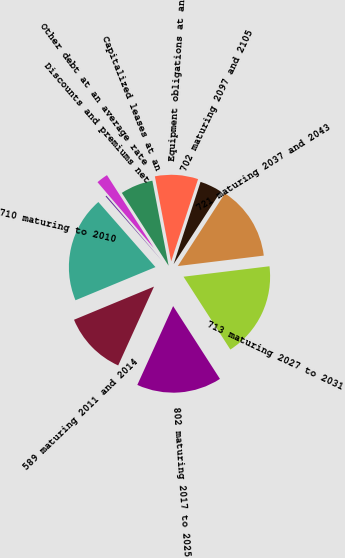<chart> <loc_0><loc_0><loc_500><loc_500><pie_chart><fcel>710 maturing to 2010<fcel>589 maturing 2011 and 2014<fcel>802 maturing 2017 to 2025<fcel>713 maturing 2027 to 2031<fcel>721 maturing 2037 and 2043<fcel>702 maturing 2097 and 2105<fcel>Equipment obligations at an<fcel>Capitalized leases at an<fcel>Other debt at an average rate<fcel>Discounts and premiums net<nl><fcel>19.79%<fcel>11.96%<fcel>15.88%<fcel>17.83%<fcel>13.92%<fcel>4.12%<fcel>8.04%<fcel>6.08%<fcel>2.17%<fcel>0.21%<nl></chart> 